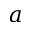Convert formula to latex. <formula><loc_0><loc_0><loc_500><loc_500>a</formula> 